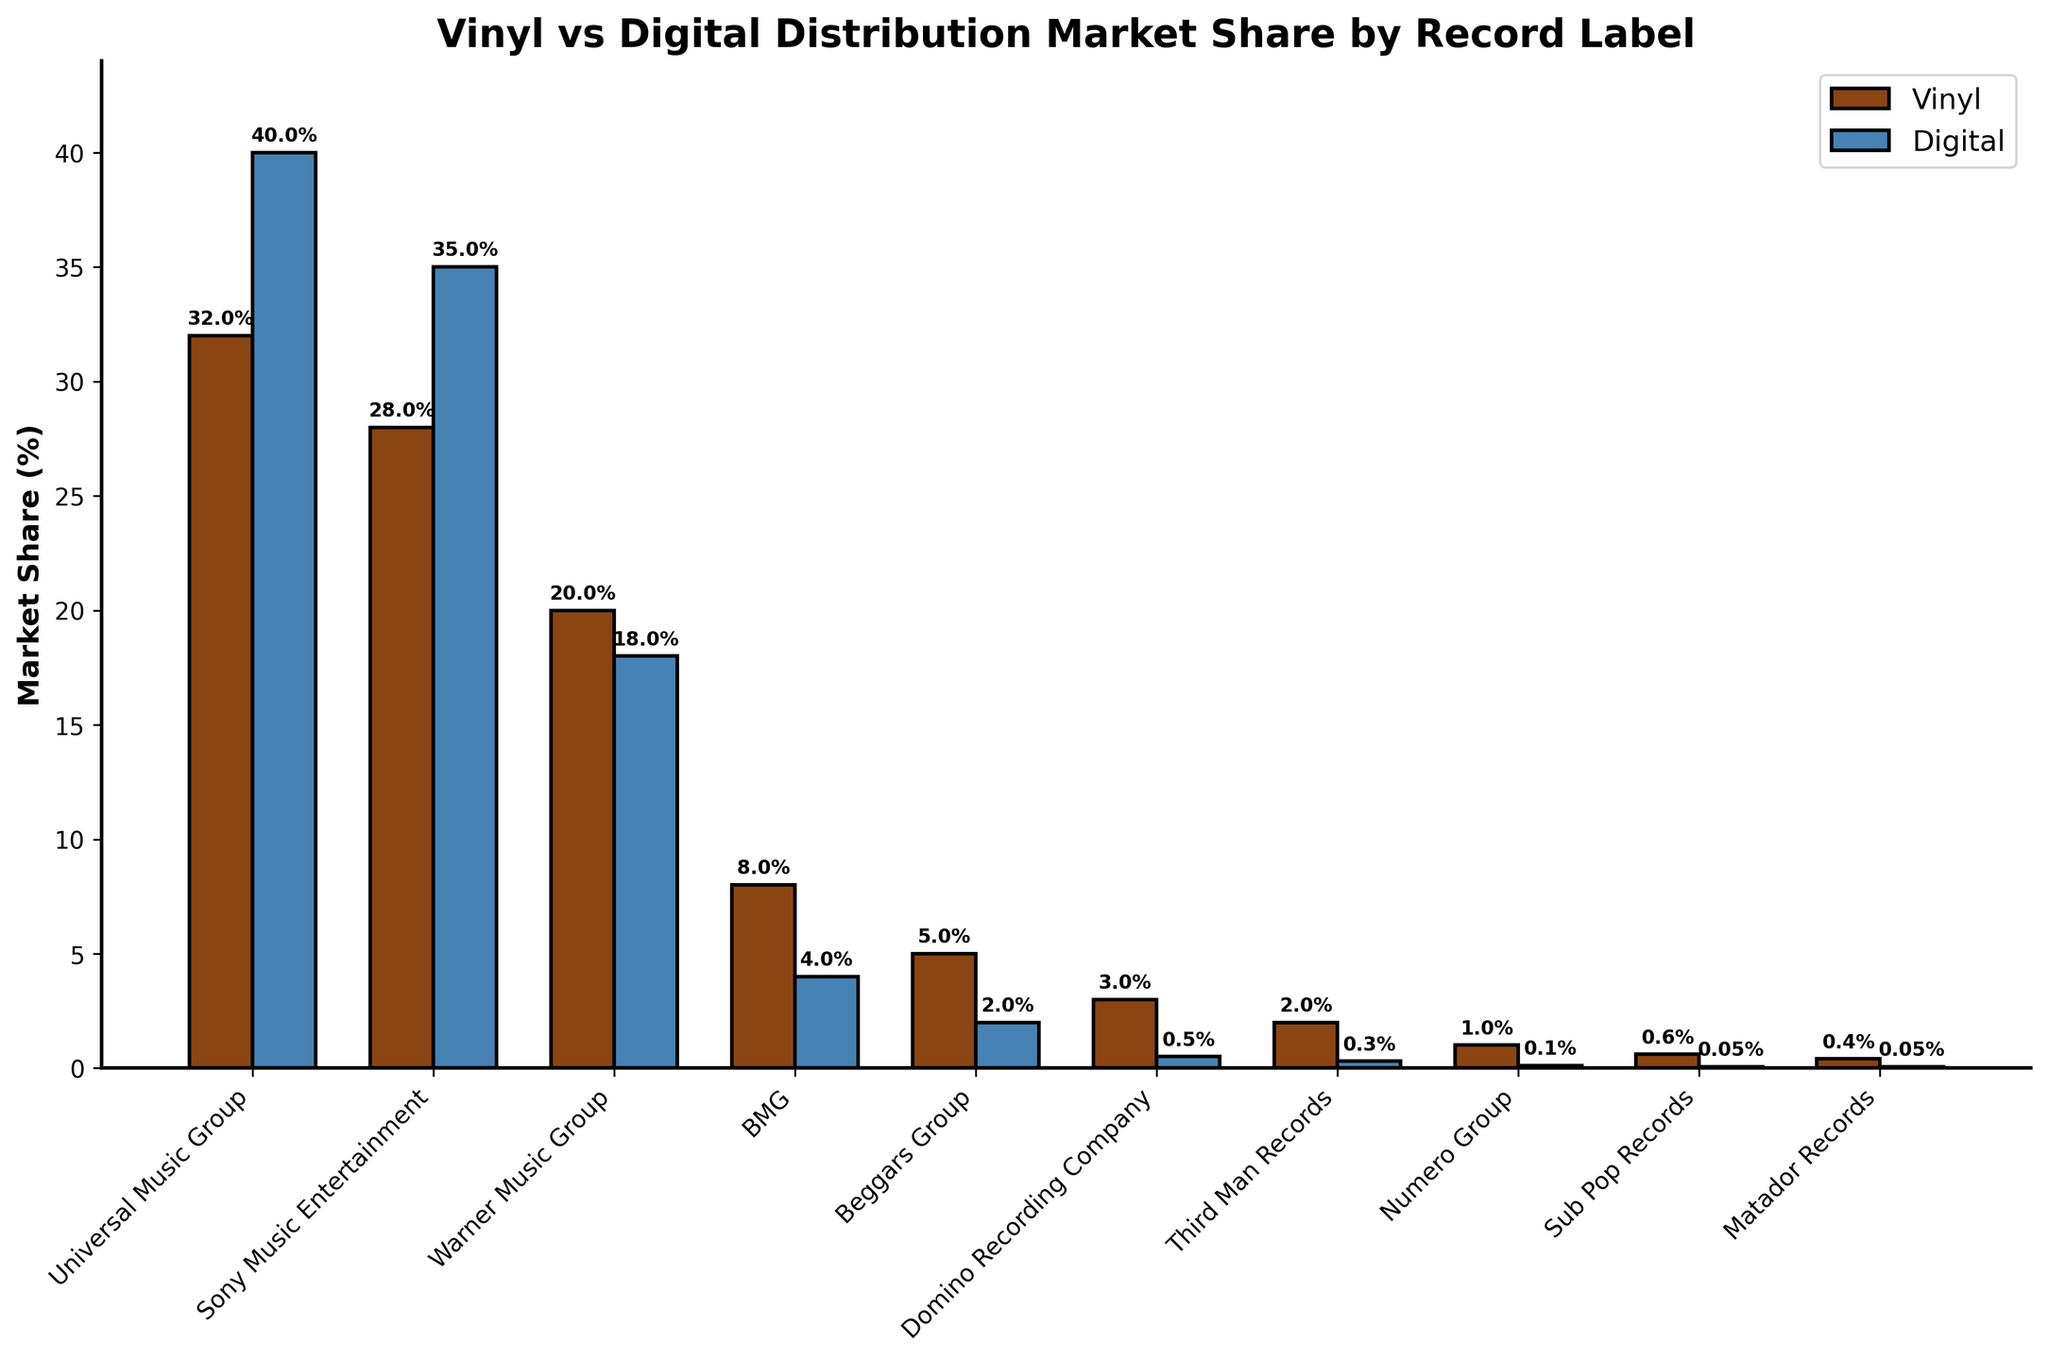Which record label has the highest market share in vinyl production? The figure shows bars representing market shares in vinyl production. The tallest bar in the vinyl section corresponds to Universal Music Group.
Answer: Universal Music Group Which record label has a larger difference between its vinyl market share and digital distribution market share? To find the largest difference, look at the height difference between vinyl and digital bars for each label and compare. Universal Music Group has the highest vinyl market share of 32% and digital 40%, so a difference of 8%; for Sony Music Entertainment, it's 28% (vinyl) and 35% (digital), so 7%. Upon comparing all, Beggars Group has vinyl 5% and digital 2%, a 3% difference—no other differences are higher.
Answer: Beggars Group Which record label has the smallest digital distribution market share? The smallest bar in the digital section corresponds to Sub Pop Records and Matador Records, both having the same height.
Answer: Sub Pop Records, Matador Records Which two record labels have the same market share percentage in digital distribution, and what is this percentage? Look at the height of the digital bars to find two bars with the same height. Sub Pop Records and Matador Records both have a digital distribution market share of 0.05%.
Answer: Sub Pop Records, Matador Records, 0.05% What is the total market share percentage combined for vinyl production across all record labels shown? Sum the market share percentages for vinyl for all record labels: 32 + 28 + 20 + 8 + 5 + 3 + 2 + 1 + 0.6 + 0.4 = 100.
Answer: 100% Among Universal Music Group, Sony Music Entertainment, and Warner Music Group, which has the closest market shares between vinyl production and digital distribution? Calculate the difference for each: Universal (32-40=8), Sony (28-35=7), Warner (20-18=2). Warner Music Group has the closest shares with a difference of 2%.
Answer: Warner Music Group What is the average digital distribution market share percentage of the top three record labels in terms of vinyl market share? Identify the top three vinyl shares: Universal Music Group (32%), Sony Music Entertainment (28%), Warner Music Group (20%). Now, for these calculate the average digital shares: (40 + 35 + 18) / 3 = 31.
Answer: 31% Which label has a vinyl production market share of less than 1% but is still listed in the figure? Look for bars in the vinyl section that are less than 1%; Sub Pop Records (0.6%) and Matador Records (0.4%) both fit.
Answer: Sub Pop Records, Matador Records How many labels have a digital market share that is exactly half of their vinyl market share or less? Compare each: Universal (32 vs 40), Sony (28 vs 35), Warner (20 vs 18), BMG (8 vs 4), Beggars (5 vs 2), Domino (3 vs 0.5), Third Man (2 vs 0.3), Numero (1 vs 0.1), Sub Pop (0.6 vs 0.05), Matador (0.4 vs 0.05). By checking these conditions, Domino, Third Man Records, Numero Group, Sub Pop Records, and Matador Records qualify.
Answer: 5 Which record label has the most substantial presence in digital distribution but a significantly lower presence in vinyl production? Look for the highest bar in the digital section that is significantly higher than its vinyl counterpart. Universal Music Group has 40% (digital) vs 32% (vinyl) compared to other combinations.
Answer: Universal Music Group 